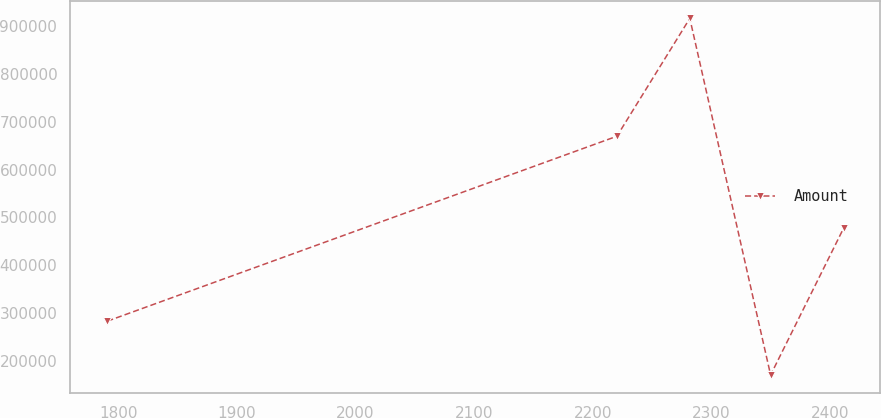Convert chart to OTSL. <chart><loc_0><loc_0><loc_500><loc_500><line_chart><ecel><fcel>Amount<nl><fcel>1790.93<fcel>282971<nl><fcel>2220.36<fcel>669598<nl><fcel>2281.79<fcel>916004<nl><fcel>2349.88<fcel>170375<nl><fcel>2411.31<fcel>476953<nl></chart> 